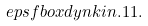<formula> <loc_0><loc_0><loc_500><loc_500>\ e p s f b o x { d y n k i n . 1 1 } .</formula> 